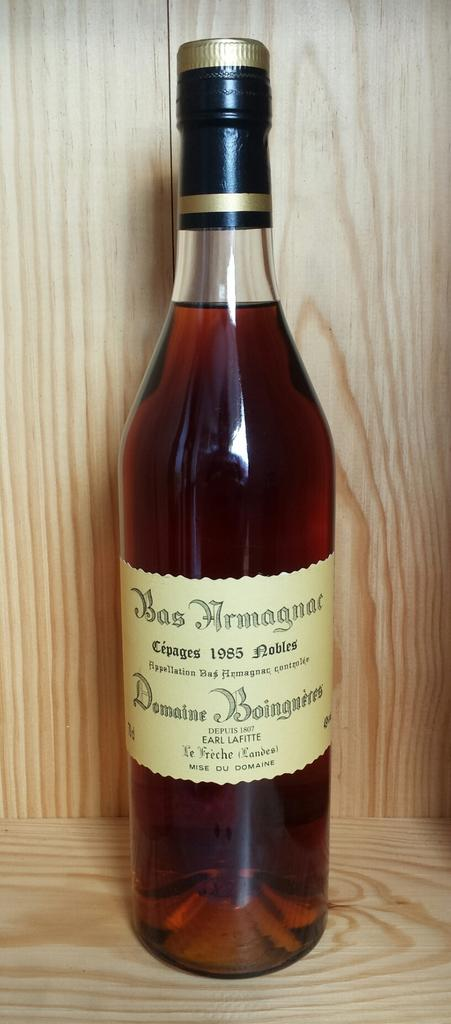<image>
Provide a brief description of the given image. the word Bas that is on a wine bottle 